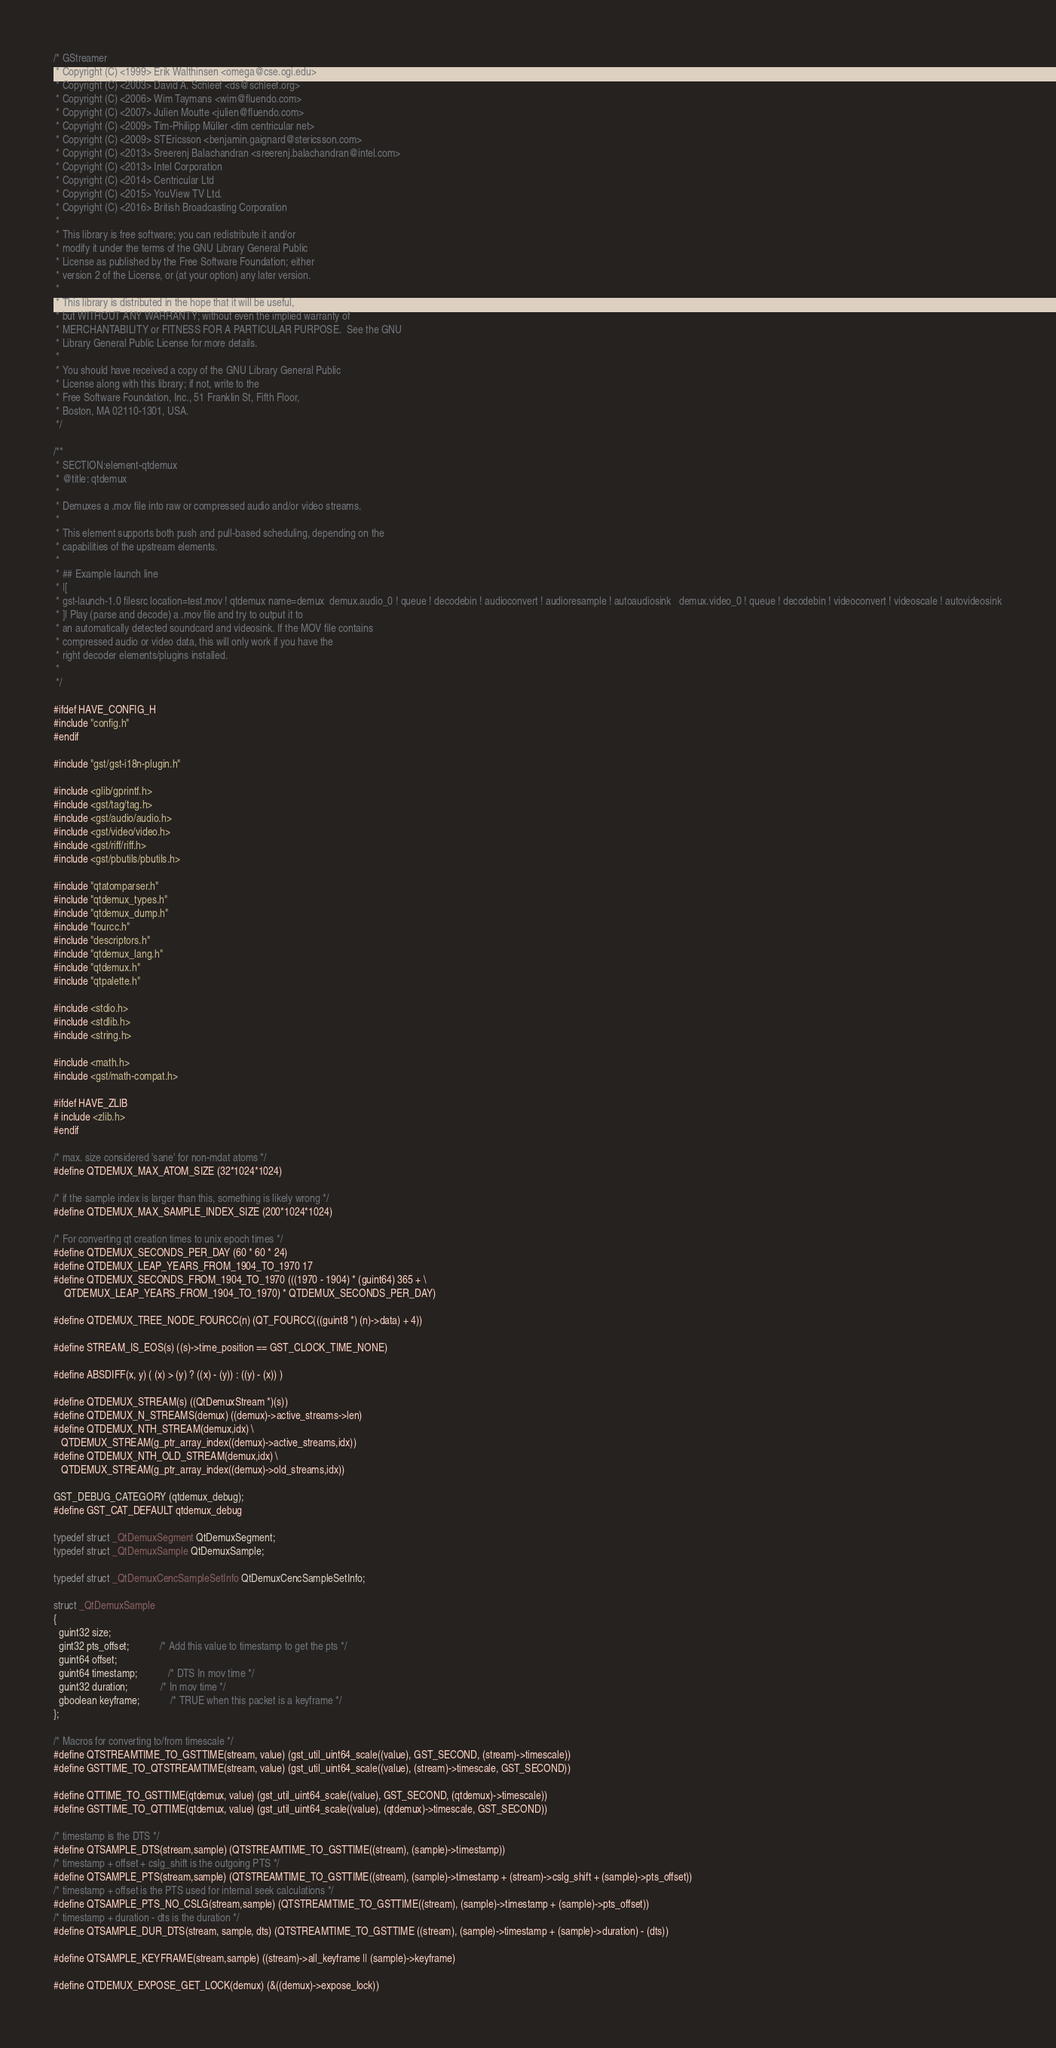<code> <loc_0><loc_0><loc_500><loc_500><_C_>/* GStreamer
 * Copyright (C) <1999> Erik Walthinsen <omega@cse.ogi.edu>
 * Copyright (C) <2003> David A. Schleef <ds@schleef.org>
 * Copyright (C) <2006> Wim Taymans <wim@fluendo.com>
 * Copyright (C) <2007> Julien Moutte <julien@fluendo.com>
 * Copyright (C) <2009> Tim-Philipp Müller <tim centricular net>
 * Copyright (C) <2009> STEricsson <benjamin.gaignard@stericsson.com>
 * Copyright (C) <2013> Sreerenj Balachandran <sreerenj.balachandran@intel.com>
 * Copyright (C) <2013> Intel Corporation
 * Copyright (C) <2014> Centricular Ltd
 * Copyright (C) <2015> YouView TV Ltd.
 * Copyright (C) <2016> British Broadcasting Corporation
 *
 * This library is free software; you can redistribute it and/or
 * modify it under the terms of the GNU Library General Public
 * License as published by the Free Software Foundation; either
 * version 2 of the License, or (at your option) any later version.
 *
 * This library is distributed in the hope that it will be useful,
 * but WITHOUT ANY WARRANTY; without even the implied warranty of
 * MERCHANTABILITY or FITNESS FOR A PARTICULAR PURPOSE.  See the GNU
 * Library General Public License for more details.
 *
 * You should have received a copy of the GNU Library General Public
 * License along with this library; if not, write to the
 * Free Software Foundation, Inc., 51 Franklin St, Fifth Floor,
 * Boston, MA 02110-1301, USA.
 */

/**
 * SECTION:element-qtdemux
 * @title: qtdemux
 *
 * Demuxes a .mov file into raw or compressed audio and/or video streams.
 *
 * This element supports both push and pull-based scheduling, depending on the
 * capabilities of the upstream elements.
 *
 * ## Example launch line
 * |[
 * gst-launch-1.0 filesrc location=test.mov ! qtdemux name=demux  demux.audio_0 ! queue ! decodebin ! audioconvert ! audioresample ! autoaudiosink   demux.video_0 ! queue ! decodebin ! videoconvert ! videoscale ! autovideosink
 * ]| Play (parse and decode) a .mov file and try to output it to
 * an automatically detected soundcard and videosink. If the MOV file contains
 * compressed audio or video data, this will only work if you have the
 * right decoder elements/plugins installed.
 *
 */

#ifdef HAVE_CONFIG_H
#include "config.h"
#endif

#include "gst/gst-i18n-plugin.h"

#include <glib/gprintf.h>
#include <gst/tag/tag.h>
#include <gst/audio/audio.h>
#include <gst/video/video.h>
#include <gst/riff/riff.h>
#include <gst/pbutils/pbutils.h>

#include "qtatomparser.h"
#include "qtdemux_types.h"
#include "qtdemux_dump.h"
#include "fourcc.h"
#include "descriptors.h"
#include "qtdemux_lang.h"
#include "qtdemux.h"
#include "qtpalette.h"

#include <stdio.h>
#include <stdlib.h>
#include <string.h>

#include <math.h>
#include <gst/math-compat.h>

#ifdef HAVE_ZLIB
# include <zlib.h>
#endif

/* max. size considered 'sane' for non-mdat atoms */
#define QTDEMUX_MAX_ATOM_SIZE (32*1024*1024)

/* if the sample index is larger than this, something is likely wrong */
#define QTDEMUX_MAX_SAMPLE_INDEX_SIZE (200*1024*1024)

/* For converting qt creation times to unix epoch times */
#define QTDEMUX_SECONDS_PER_DAY (60 * 60 * 24)
#define QTDEMUX_LEAP_YEARS_FROM_1904_TO_1970 17
#define QTDEMUX_SECONDS_FROM_1904_TO_1970 (((1970 - 1904) * (guint64) 365 + \
    QTDEMUX_LEAP_YEARS_FROM_1904_TO_1970) * QTDEMUX_SECONDS_PER_DAY)

#define QTDEMUX_TREE_NODE_FOURCC(n) (QT_FOURCC(((guint8 *) (n)->data) + 4))

#define STREAM_IS_EOS(s) ((s)->time_position == GST_CLOCK_TIME_NONE)

#define ABSDIFF(x, y) ( (x) > (y) ? ((x) - (y)) : ((y) - (x)) )

#define QTDEMUX_STREAM(s) ((QtDemuxStream *)(s))
#define QTDEMUX_N_STREAMS(demux) ((demux)->active_streams->len)
#define QTDEMUX_NTH_STREAM(demux,idx) \
   QTDEMUX_STREAM(g_ptr_array_index((demux)->active_streams,idx))
#define QTDEMUX_NTH_OLD_STREAM(demux,idx) \
   QTDEMUX_STREAM(g_ptr_array_index((demux)->old_streams,idx))

GST_DEBUG_CATEGORY (qtdemux_debug);
#define GST_CAT_DEFAULT qtdemux_debug

typedef struct _QtDemuxSegment QtDemuxSegment;
typedef struct _QtDemuxSample QtDemuxSample;

typedef struct _QtDemuxCencSampleSetInfo QtDemuxCencSampleSetInfo;

struct _QtDemuxSample
{
  guint32 size;
  gint32 pts_offset;            /* Add this value to timestamp to get the pts */
  guint64 offset;
  guint64 timestamp;            /* DTS In mov time */
  guint32 duration;             /* In mov time */
  gboolean keyframe;            /* TRUE when this packet is a keyframe */
};

/* Macros for converting to/from timescale */
#define QTSTREAMTIME_TO_GSTTIME(stream, value) (gst_util_uint64_scale((value), GST_SECOND, (stream)->timescale))
#define GSTTIME_TO_QTSTREAMTIME(stream, value) (gst_util_uint64_scale((value), (stream)->timescale, GST_SECOND))

#define QTTIME_TO_GSTTIME(qtdemux, value) (gst_util_uint64_scale((value), GST_SECOND, (qtdemux)->timescale))
#define GSTTIME_TO_QTTIME(qtdemux, value) (gst_util_uint64_scale((value), (qtdemux)->timescale, GST_SECOND))

/* timestamp is the DTS */
#define QTSAMPLE_DTS(stream,sample) (QTSTREAMTIME_TO_GSTTIME((stream), (sample)->timestamp))
/* timestamp + offset + cslg_shift is the outgoing PTS */
#define QTSAMPLE_PTS(stream,sample) (QTSTREAMTIME_TO_GSTTIME((stream), (sample)->timestamp + (stream)->cslg_shift + (sample)->pts_offset))
/* timestamp + offset is the PTS used for internal seek calculations */
#define QTSAMPLE_PTS_NO_CSLG(stream,sample) (QTSTREAMTIME_TO_GSTTIME((stream), (sample)->timestamp + (sample)->pts_offset))
/* timestamp + duration - dts is the duration */
#define QTSAMPLE_DUR_DTS(stream, sample, dts) (QTSTREAMTIME_TO_GSTTIME ((stream), (sample)->timestamp + (sample)->duration) - (dts))

#define QTSAMPLE_KEYFRAME(stream,sample) ((stream)->all_keyframe || (sample)->keyframe)

#define QTDEMUX_EXPOSE_GET_LOCK(demux) (&((demux)->expose_lock))</code> 